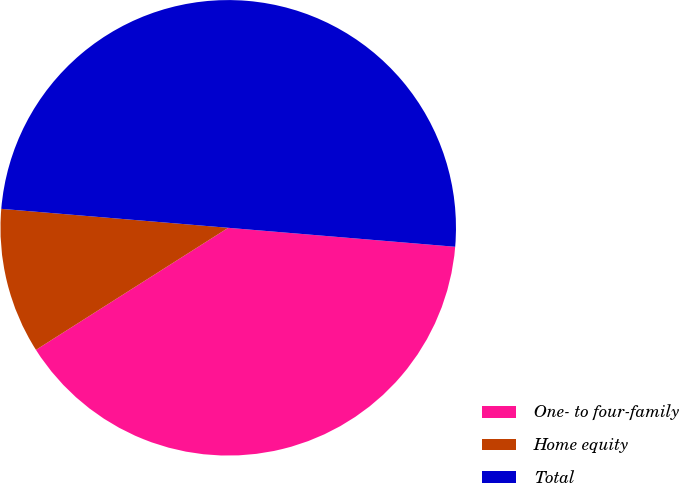Convert chart. <chart><loc_0><loc_0><loc_500><loc_500><pie_chart><fcel>One- to four-family<fcel>Home equity<fcel>Total<nl><fcel>39.67%<fcel>10.33%<fcel>50.0%<nl></chart> 